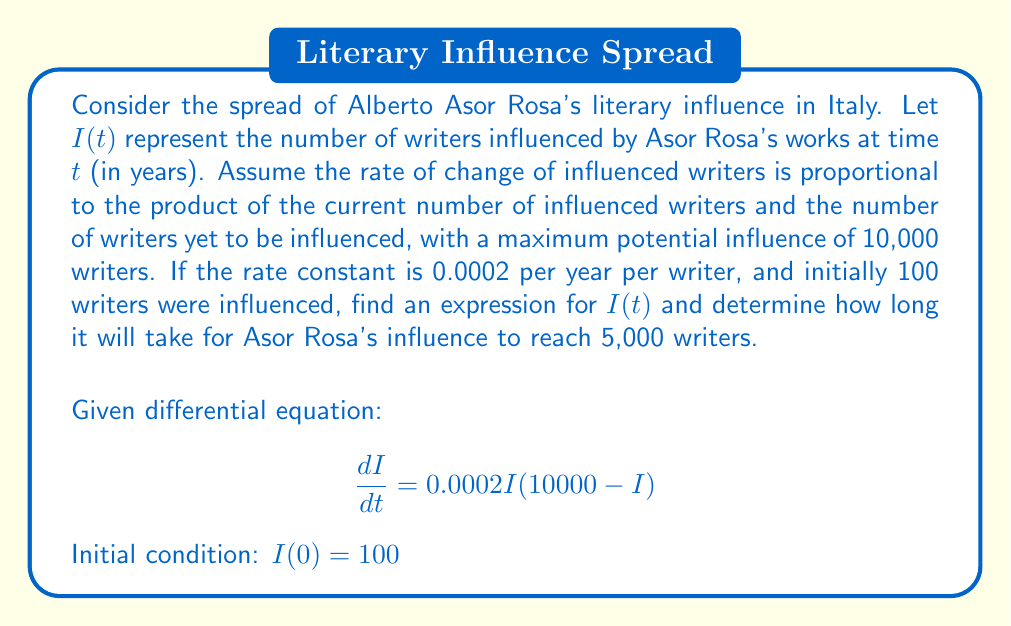Help me with this question. Let's solve this step-by-step:

1) The given differential equation is a logistic growth model:
   $$\frac{dI}{dt} = 0.0002I(10000 - I)$$

2) This can be rewritten as:
   $$\frac{dI}{dt} = 2I - 0.0002I^2$$

3) The general solution for this type of equation is:
   $$I(t) = \frac{K}{1 + Ce^{-rt}}$$
   where $K$ is the carrying capacity (10,000 in this case), $r$ is the growth rate (2 in this case), and $C$ is a constant we need to determine.

4) Substituting the initial condition $I(0) = 100$:
   $$100 = \frac{10000}{1 + C}$$

5) Solving for $C$:
   $$C = 99$$

6) Therefore, the solution is:
   $$I(t) = \frac{10000}{1 + 99e^{-2t}}$$

7) To find when $I(t) = 5000$, we solve:
   $$5000 = \frac{10000}{1 + 99e^{-2t}}$$

8) Simplifying:
   $$1 + 99e^{-2t} = 2$$
   $$99e^{-2t} = 1$$
   $$e^{-2t} = \frac{1}{99}$$

9) Taking the natural log of both sides:
   $$-2t = \ln(\frac{1}{99})$$
   $$t = -\frac{1}{2}\ln(\frac{1}{99}) = \frac{1}{2}\ln(99) \approx 2.3 \text{ years}$$
Answer: $I(t) = \frac{10000}{1 + 99e^{-2t}}$; approximately 2.3 years to reach 5,000 writers. 